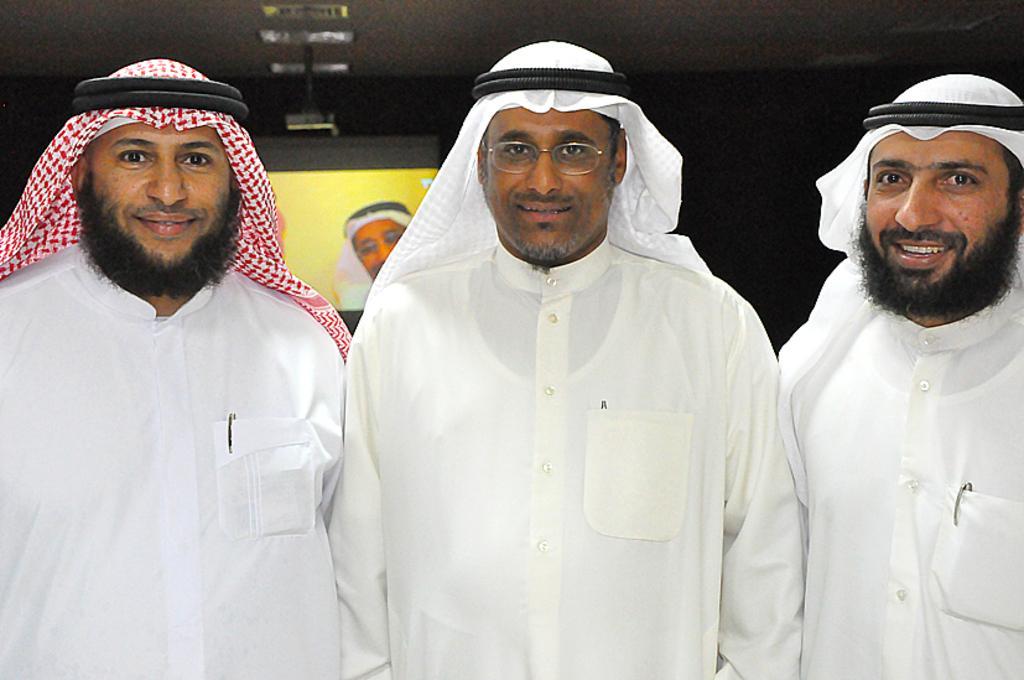Could you give a brief overview of what you see in this image? In this image we can see three persons standing and smiling. In the background we can see the display screen and also the ceiling with the lights. 